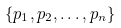<formula> <loc_0><loc_0><loc_500><loc_500>\{ p _ { 1 } , p _ { 2 } , \dots , p _ { n } \}</formula> 